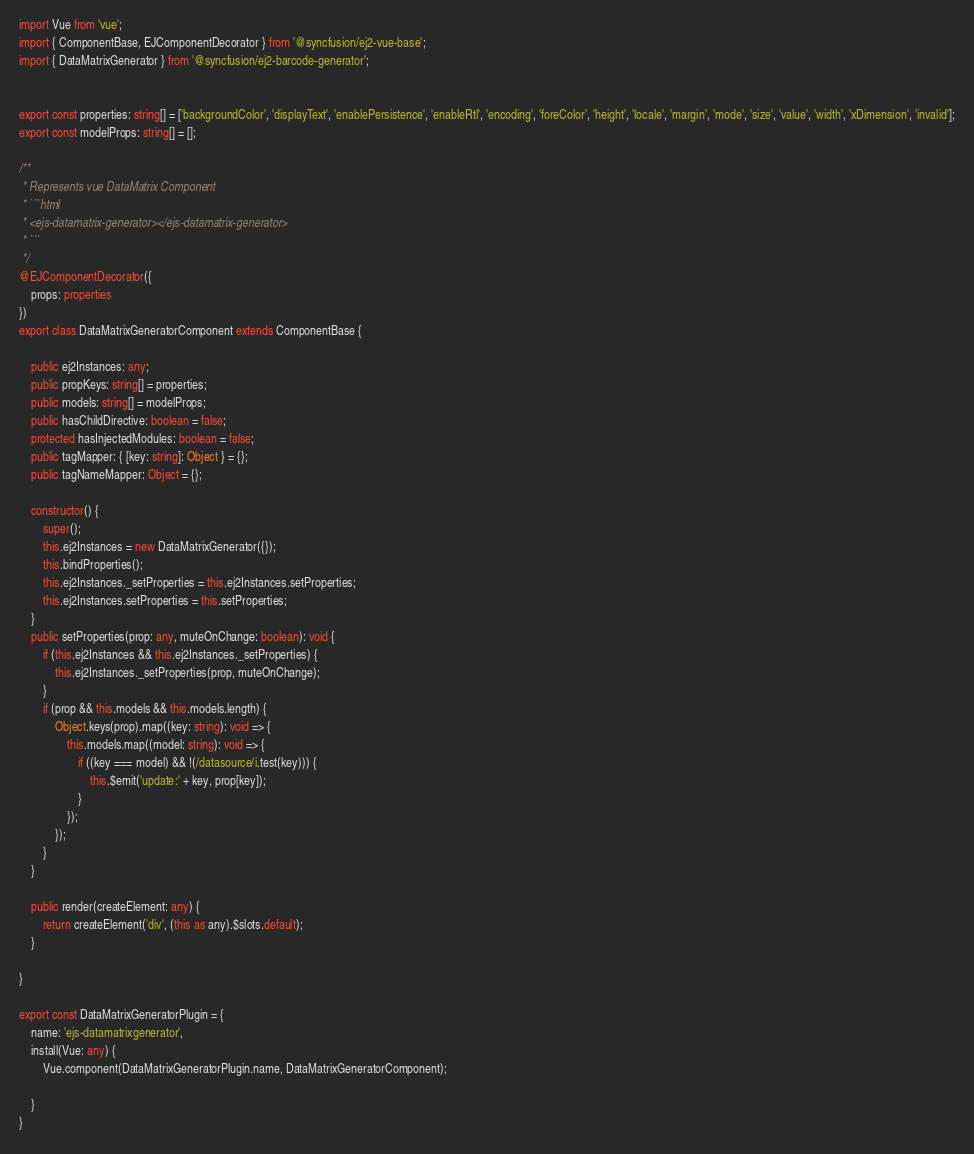Convert code to text. <code><loc_0><loc_0><loc_500><loc_500><_TypeScript_>import Vue from 'vue';
import { ComponentBase, EJComponentDecorator } from '@syncfusion/ej2-vue-base';
import { DataMatrixGenerator } from '@syncfusion/ej2-barcode-generator';


export const properties: string[] = ['backgroundColor', 'displayText', 'enablePersistence', 'enableRtl', 'encoding', 'foreColor', 'height', 'locale', 'margin', 'mode', 'size', 'value', 'width', 'xDimension', 'invalid'];
export const modelProps: string[] = [];

/**
 * Represents vue DataMatrix Component
 * ```html
 * <ejs-datamatrix-generator></ejs-datamatrix-generator>
 * ```
 */
@EJComponentDecorator({
    props: properties
})
export class DataMatrixGeneratorComponent extends ComponentBase {
    
    public ej2Instances: any;
    public propKeys: string[] = properties;
    public models: string[] = modelProps;
    public hasChildDirective: boolean = false;
    protected hasInjectedModules: boolean = false;
    public tagMapper: { [key: string]: Object } = {};
    public tagNameMapper: Object = {};
    
    constructor() {
        super();
        this.ej2Instances = new DataMatrixGenerator({});
        this.bindProperties();
        this.ej2Instances._setProperties = this.ej2Instances.setProperties;
        this.ej2Instances.setProperties = this.setProperties;
    }
    public setProperties(prop: any, muteOnChange: boolean): void {
        if (this.ej2Instances && this.ej2Instances._setProperties) {
            this.ej2Instances._setProperties(prop, muteOnChange);
        }
        if (prop && this.models && this.models.length) {
            Object.keys(prop).map((key: string): void => {
                this.models.map((model: string): void => {
                    if ((key === model) && !(/datasource/i.test(key))) {
                        this.$emit('update:' + key, prop[key]);
                    }
                });
            });
        }
    }

    public render(createElement: any) {
        return createElement('div', (this as any).$slots.default);
    }
    
}

export const DataMatrixGeneratorPlugin = {
    name: 'ejs-datamatrixgenerator',
    install(Vue: any) {
        Vue.component(DataMatrixGeneratorPlugin.name, DataMatrixGeneratorComponent);

    }
}
</code> 